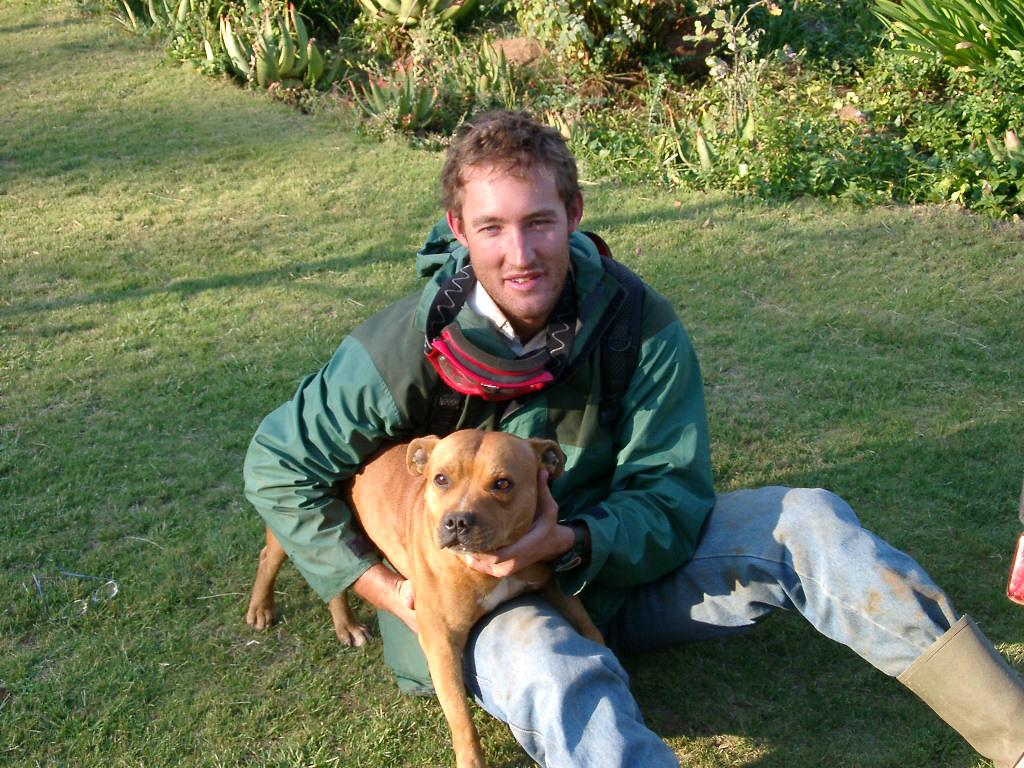What is the main subject of the image? There is a person in the image. What is the person doing in the image? The person is holding a dog with his hands. What can be seen in the background of the image? There is a group of plants in the background of the image. What type of industry can be seen in the background of the image? There is no industry present in the image; it features a person holding a dog and a group of plants in the background. How many children are visible in the image? There are no children present in the image. 